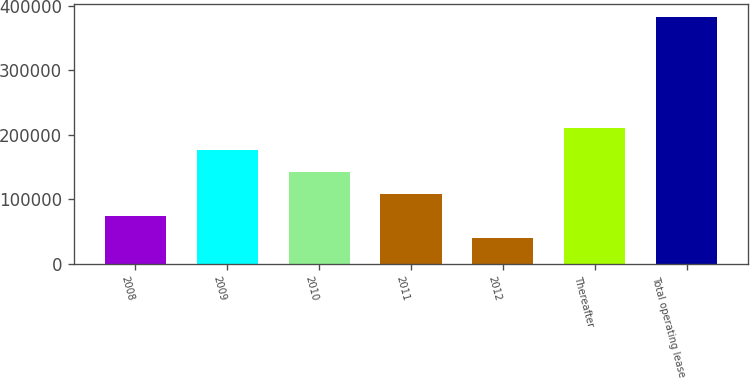Convert chart. <chart><loc_0><loc_0><loc_500><loc_500><bar_chart><fcel>2008<fcel>2009<fcel>2010<fcel>2011<fcel>2012<fcel>Thereafter<fcel>Total operating lease<nl><fcel>73623.7<fcel>176634<fcel>142297<fcel>107960<fcel>39287<fcel>210970<fcel>382654<nl></chart> 